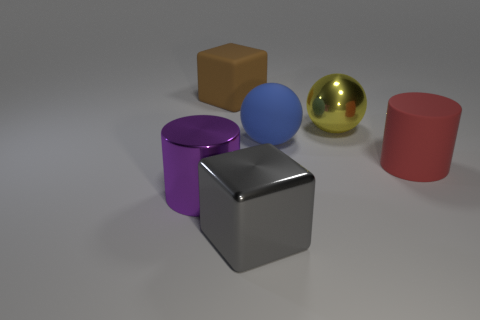Add 3 big blue matte objects. How many objects exist? 9 Subtract all cylinders. How many objects are left? 4 Subtract all brown rubber objects. Subtract all large balls. How many objects are left? 3 Add 1 big gray shiny blocks. How many big gray shiny blocks are left? 2 Add 1 brown spheres. How many brown spheres exist? 1 Subtract 0 blue cylinders. How many objects are left? 6 